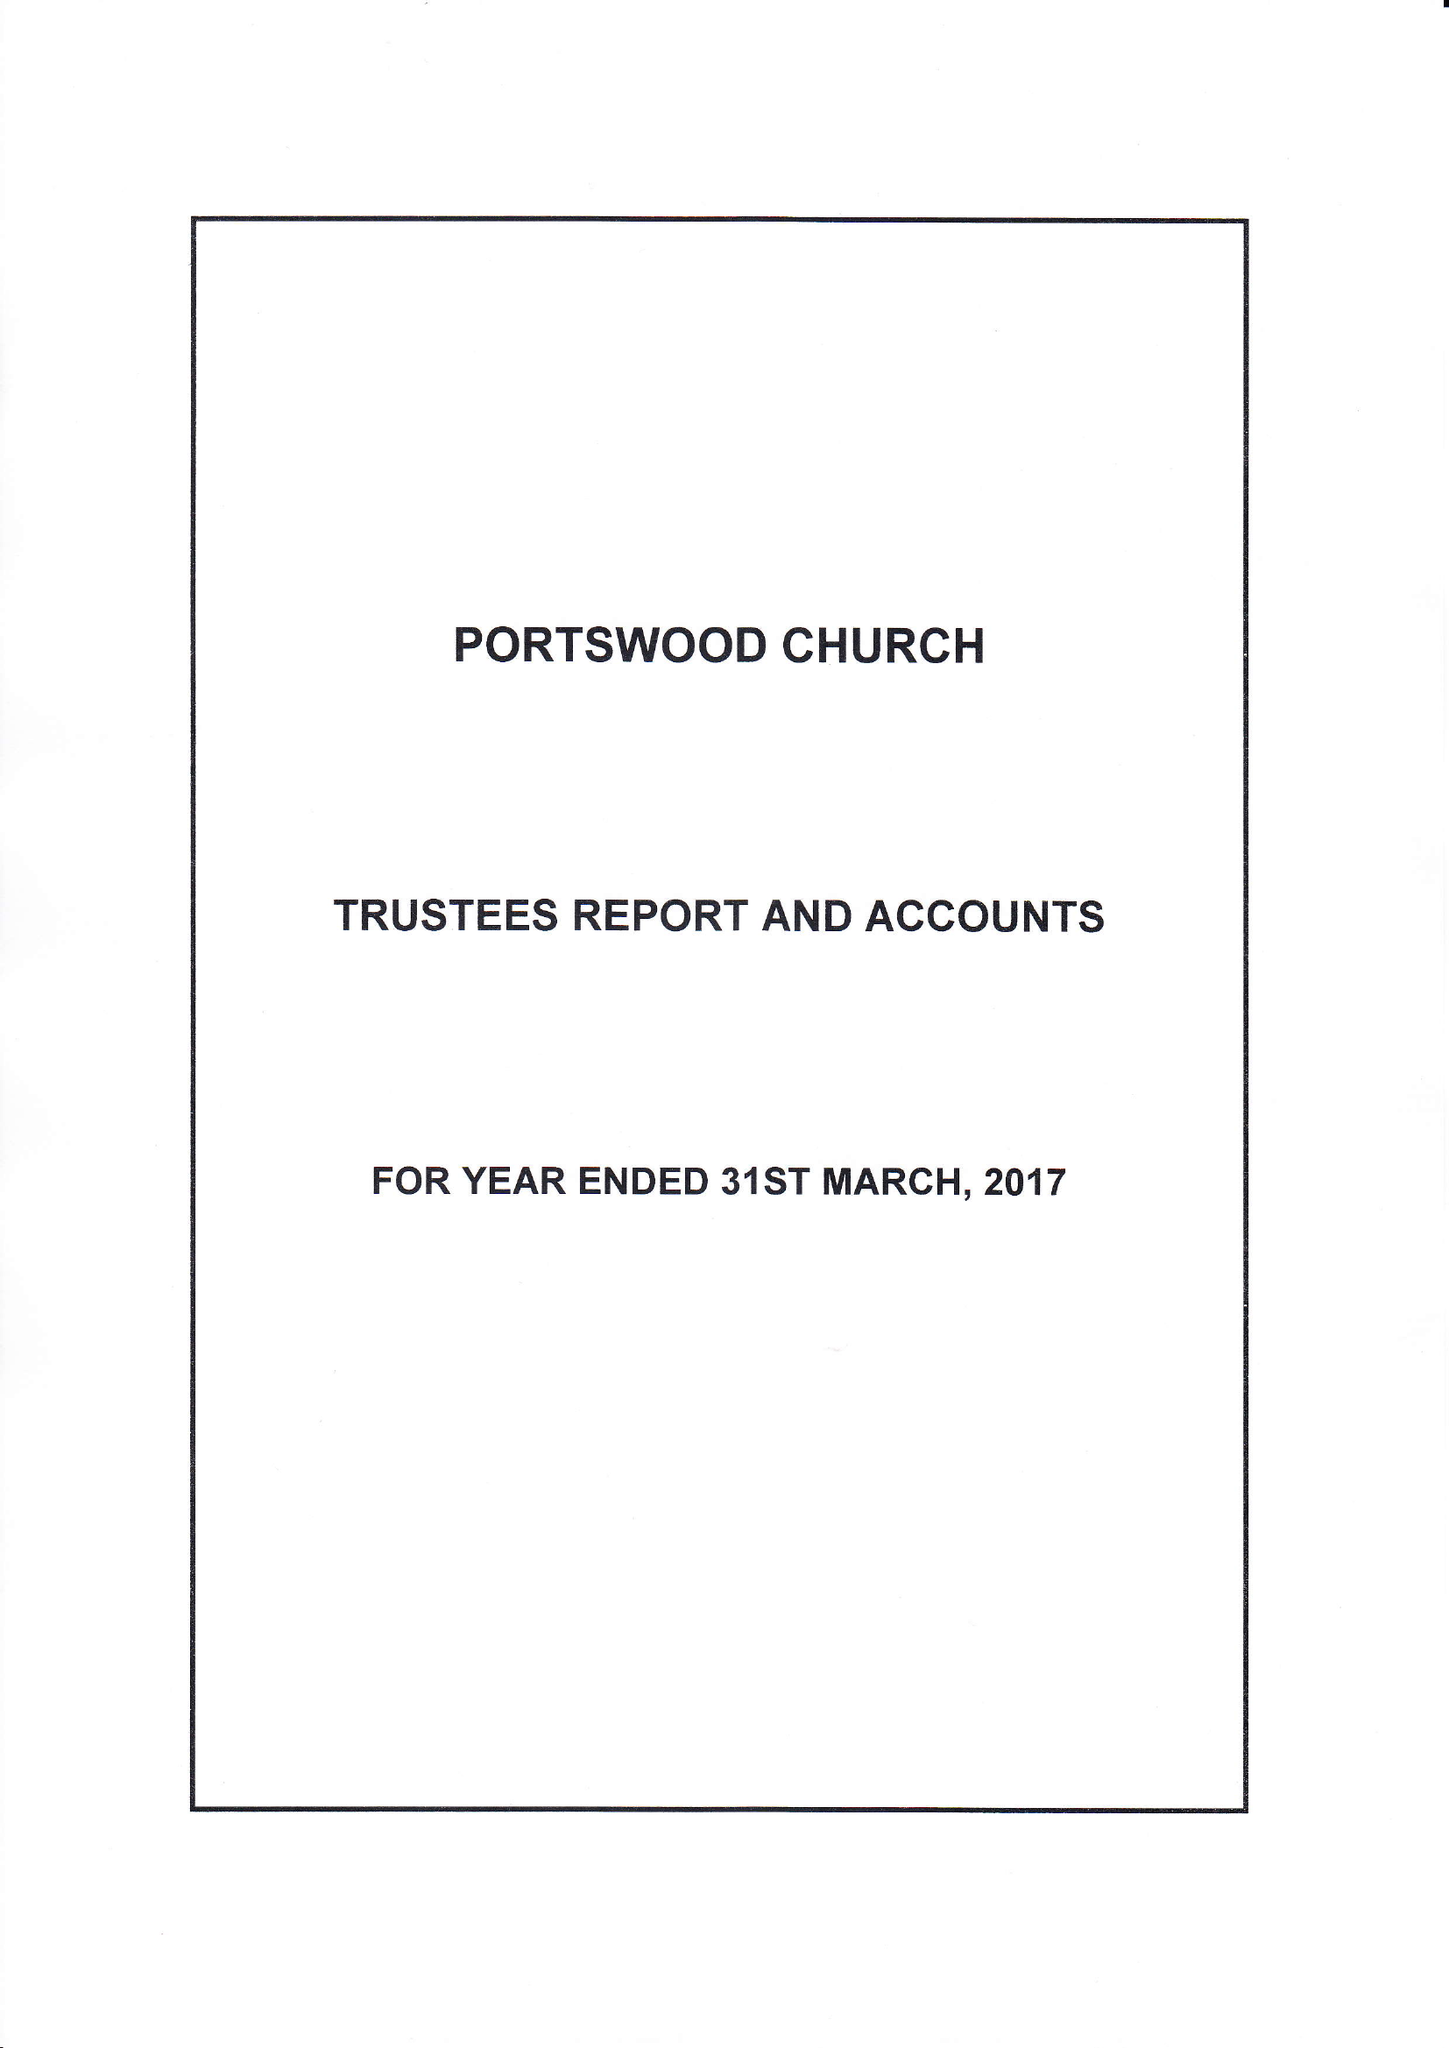What is the value for the charity_number?
Answer the question using a single word or phrase. 248769 